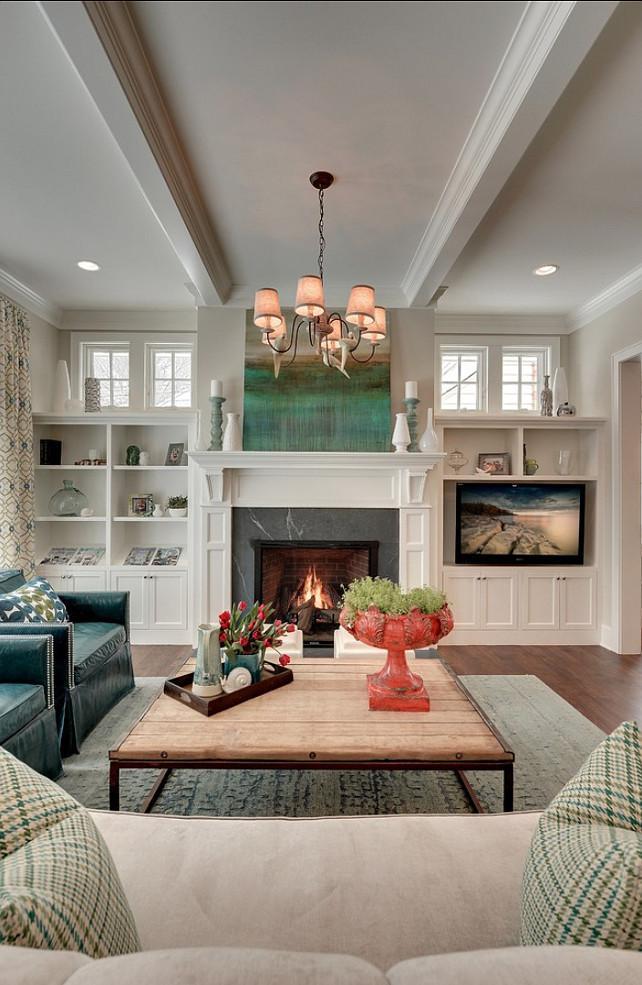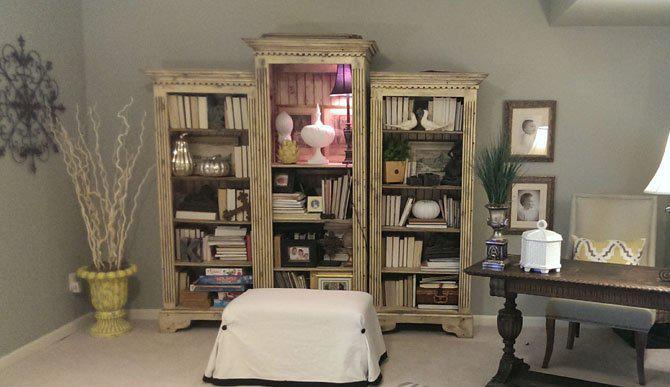The first image is the image on the left, the second image is the image on the right. Analyze the images presented: Is the assertion "One image shows a room with peaked, beamed ceiling above bookshelves and other furniture." valid? Answer yes or no. No. 